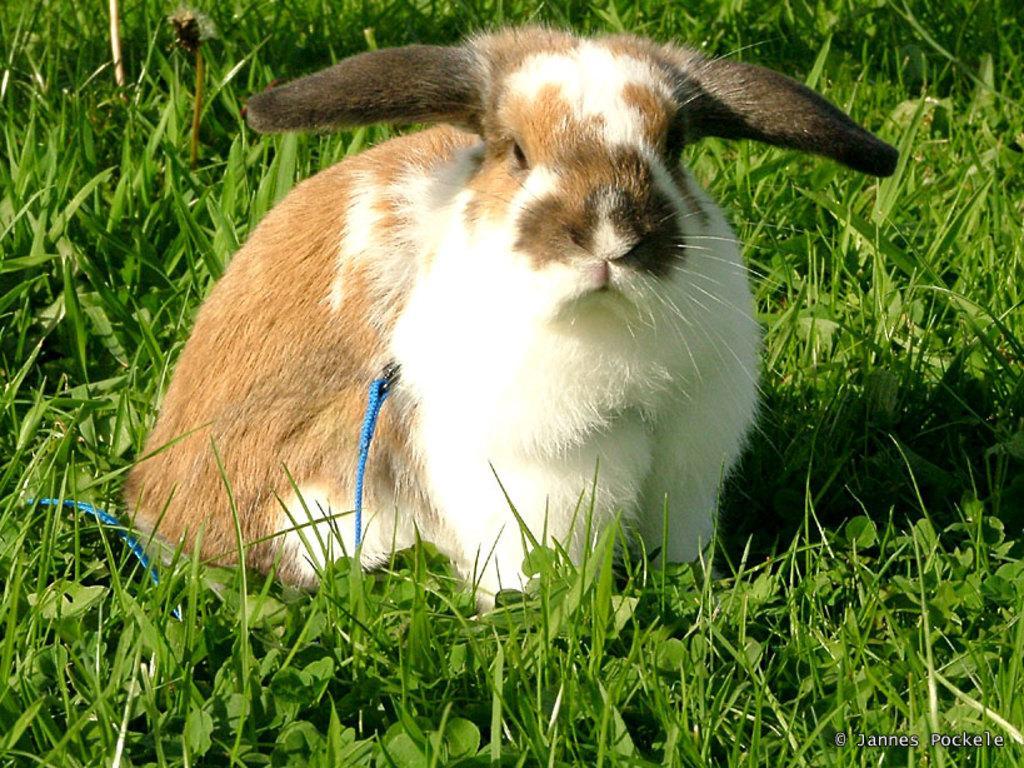Could you give a brief overview of what you see in this image? In the foreground I can see an animal on grass and a text. This image is taken may be during a day. 